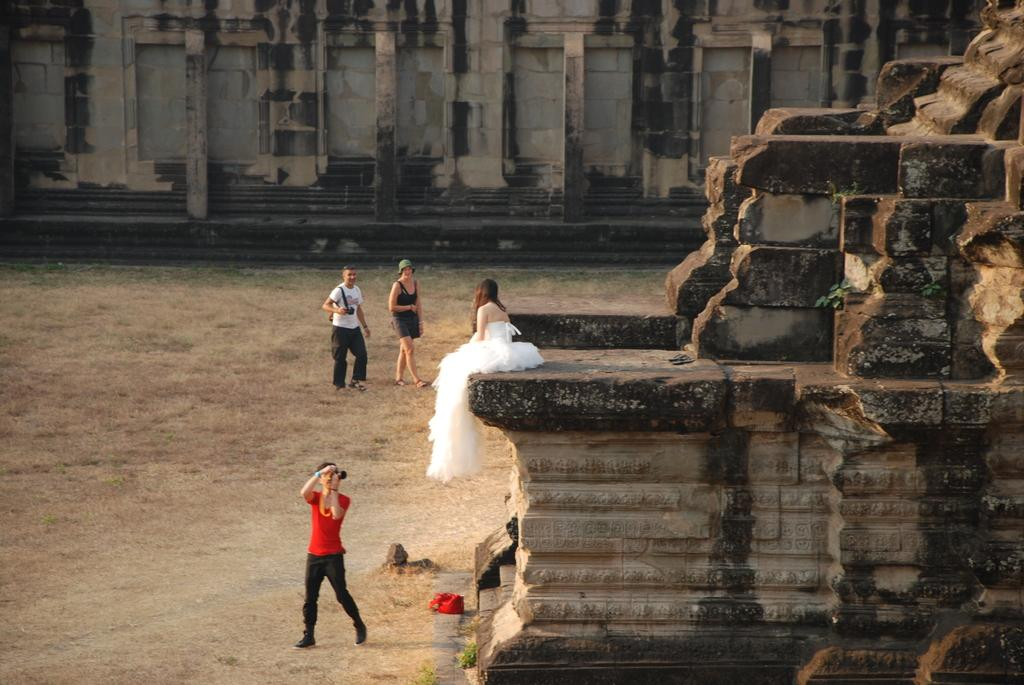What can be seen in the foreground of the picture? In the foreground of the picture, there are people, an old construction, grass, a bag, and soil. Can you describe the people in the foreground? The people in the foreground are not described in the facts, so we cannot provide any details about them. What is the condition of the soil in the foreground? The facts do not specify the condition of the soil, so we cannot provide any details about it. What is visible in the background of the picture? In the background of the picture, there is a wall. Where is the monkey's nest located in the image? There is no monkey or nest present in the image. What type of cast is visible on the wall in the background? There is no cast visible on the wall in the background; only the wall is mentioned in the facts. 